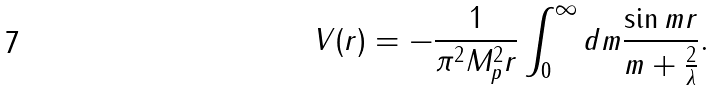Convert formula to latex. <formula><loc_0><loc_0><loc_500><loc_500>V ( r ) = - \frac { 1 } { \pi ^ { 2 } M _ { p } ^ { 2 } r } \int _ { 0 } ^ { \infty } d m \frac { \sin m r } { m + \frac { 2 } { \lambda } } .</formula> 